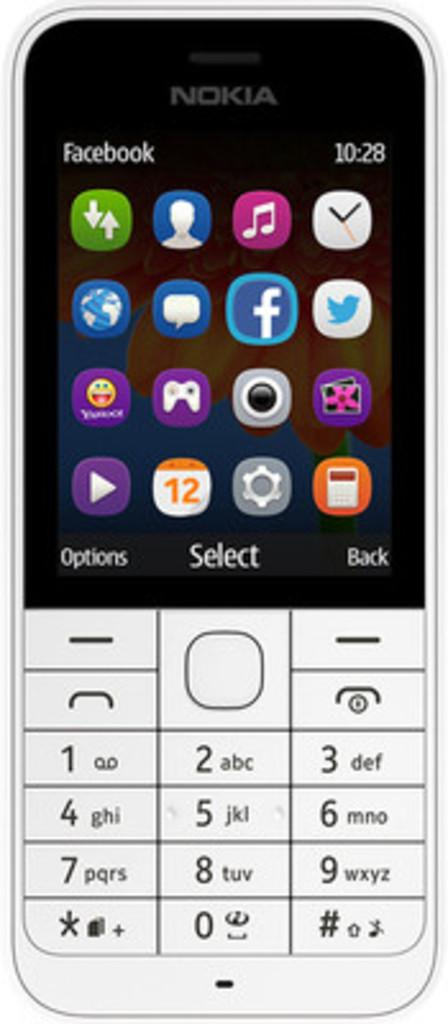Provide a one-sentence caption for the provided image. The Nokia phone image has Facebook at the top of the screen. 